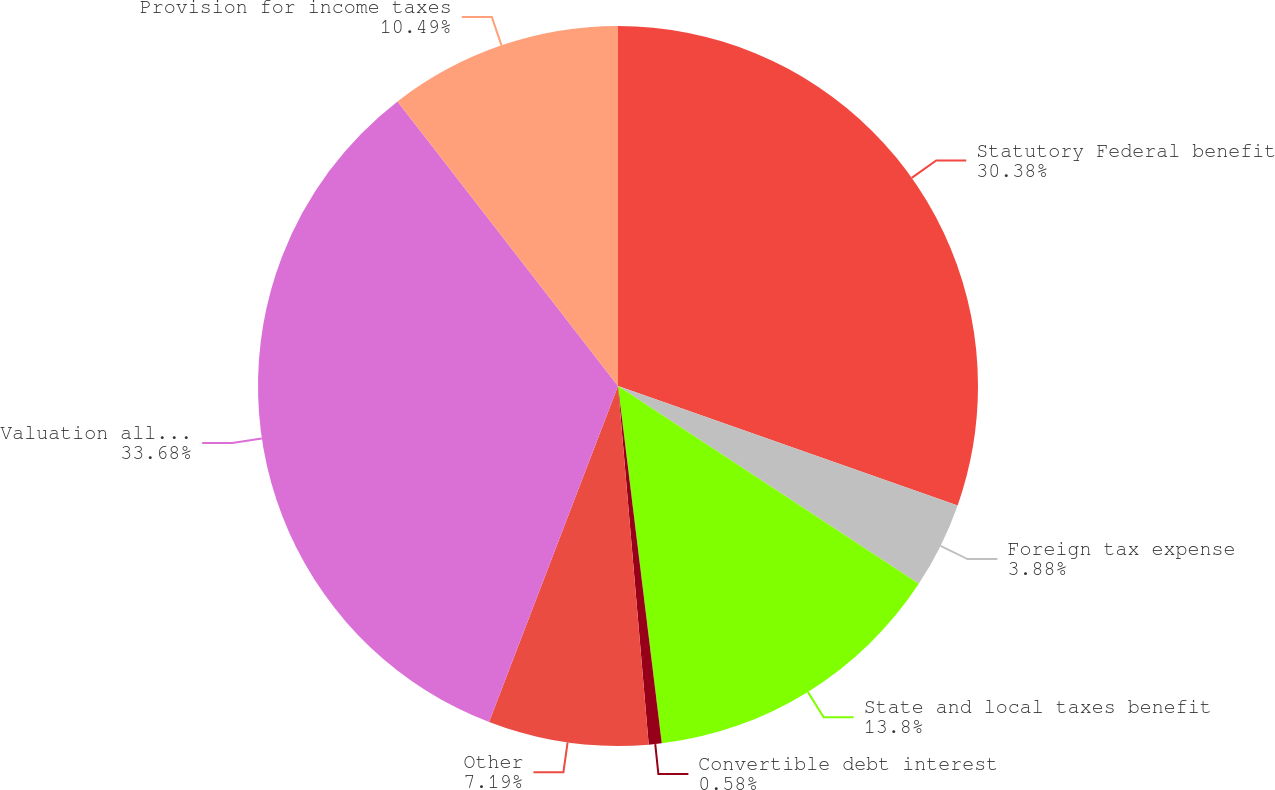<chart> <loc_0><loc_0><loc_500><loc_500><pie_chart><fcel>Statutory Federal benefit<fcel>Foreign tax expense<fcel>State and local taxes benefit<fcel>Convertible debt interest<fcel>Other<fcel>Valuation allowance<fcel>Provision for income taxes<nl><fcel>30.38%<fcel>3.88%<fcel>13.8%<fcel>0.58%<fcel>7.19%<fcel>33.68%<fcel>10.49%<nl></chart> 